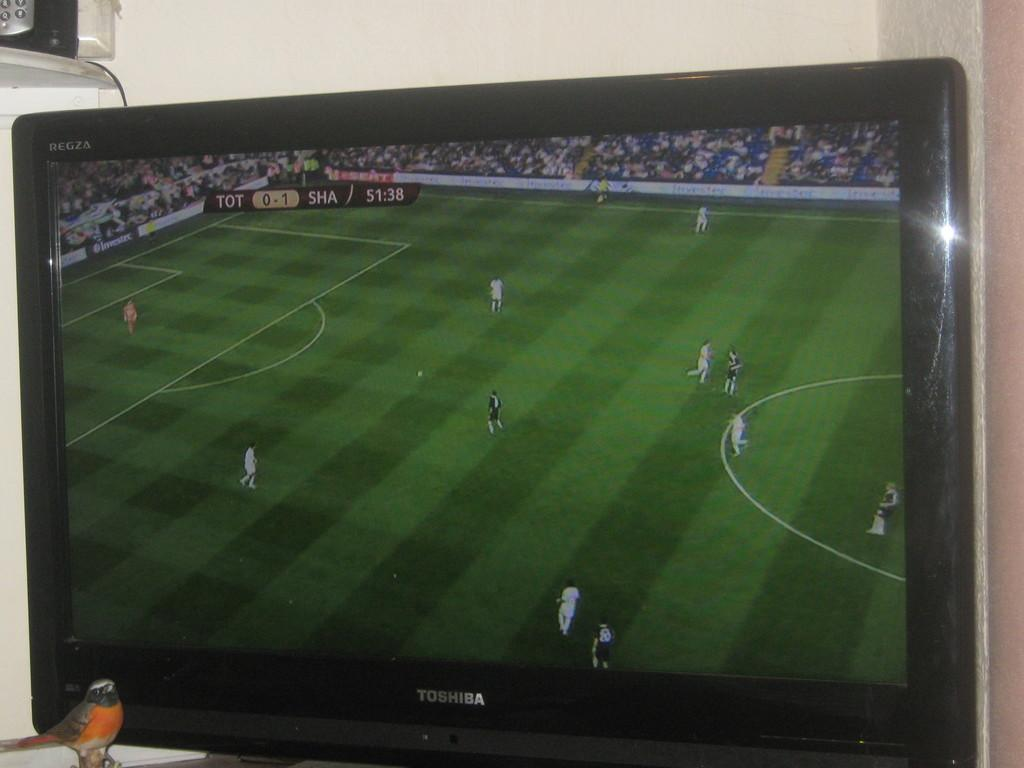<image>
Write a terse but informative summary of the picture. A little robin redbreast sits in front of a black Toshiba tv. 